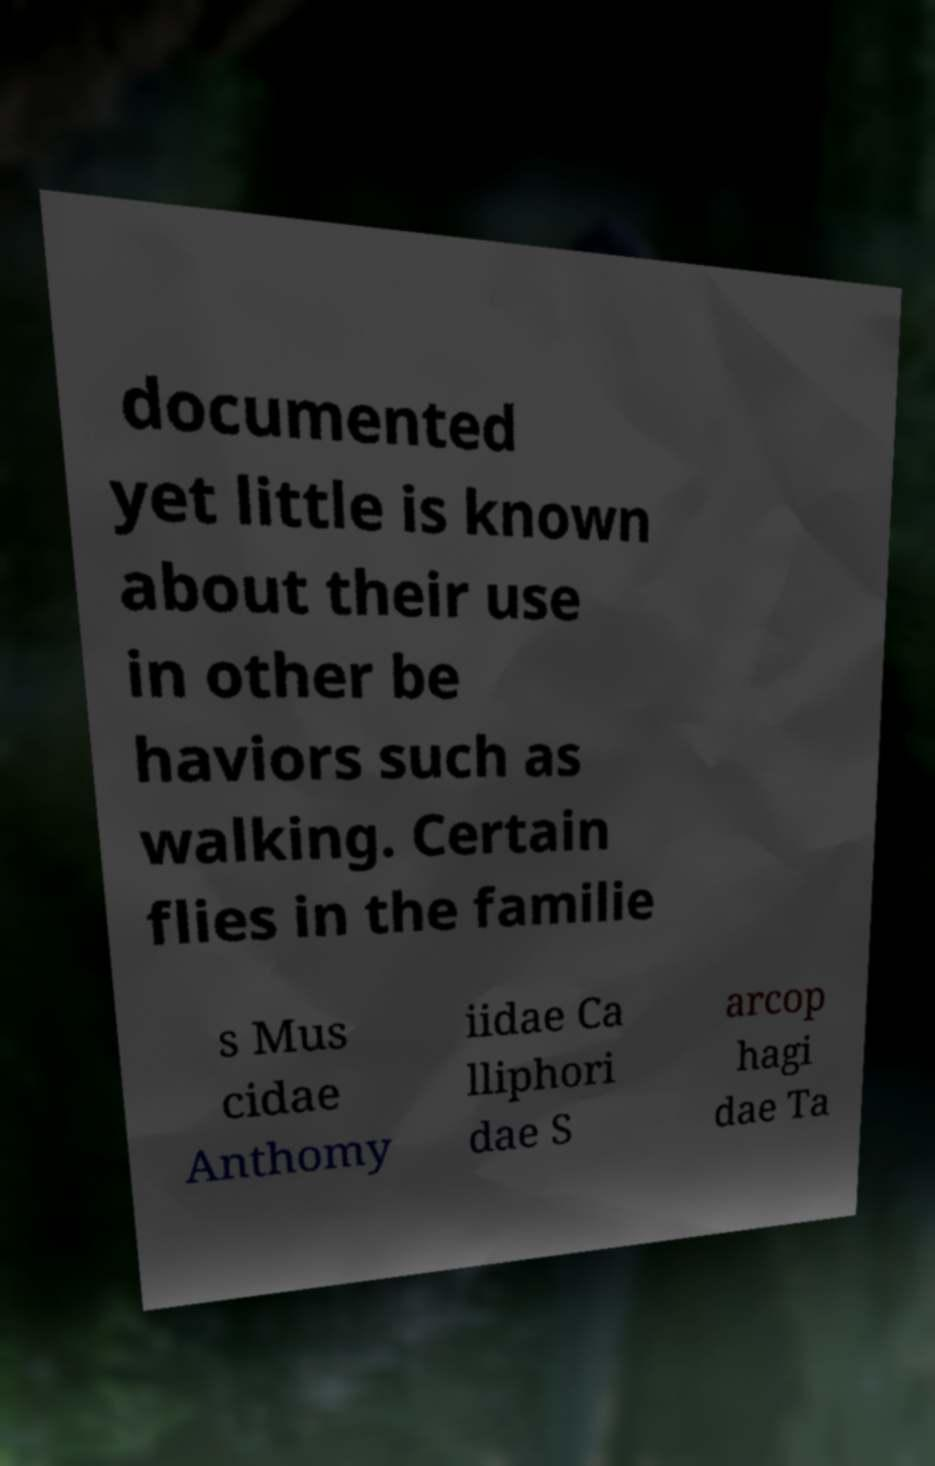There's text embedded in this image that I need extracted. Can you transcribe it verbatim? documented yet little is known about their use in other be haviors such as walking. Certain flies in the familie s Mus cidae Anthomy iidae Ca lliphori dae S arcop hagi dae Ta 